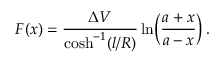Convert formula to latex. <formula><loc_0><loc_0><loc_500><loc_500>F ( x ) = \frac { \Delta V } { \cosh ^ { - 1 } ( l / R ) } \ln \, \left ( \frac { a + x } { a - x } \right ) .</formula> 